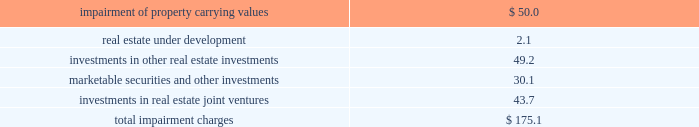Latin american investments during 2009 , the company acquired a land parcel located in rio clara , brazil through a newly formed consolidated joint venture in which the company has a 70% ( 70 % ) controlling ownership interest for a purchase price of 3.3 million brazilian reals ( approximately usd $ 1.5 million ) .
This parcel will be developed into a 48000 square foot retail shopping center .
Additionally , during 2009 , the company acquired a land parcel located in san luis potosi , mexico , through an unconsolidated joint venture in which the company has a noncontrolling interest , for an aggregate purchase price of approximately $ 0.8 million .
The company recognized equity in income from its unconsolidated mexican investments in real estate joint ventures of approximately $ 7.0 million , $ 17.1 million , and $ 5.2 million during 2009 , 2008 and 2007 , respectively .
The company recognized equity in income from its unconsolidated chilean investments in real estate joint ventures of approximately $ 0.4 million , $ 0.2 and $ 0.1 million during 2009 , 2008 and 2007 , respectively .
The company 2019s revenues from its consolidated mexican subsidiaries aggregated approximately $ 23.4 million , $ 20.3 million , $ 8.5 million during 2009 , 2008 and 2007 , respectively .
The company 2019s revenues from its consolidated brazilian subsidiaries aggregated approximately $ 1.5 million and $ 0.4 million during 2009 and 2008 , respectively .
The company 2019s revenues from its consolidated chilean subsidiaries aggregated less than $ 100000 during 2009 and 2008 , respectively .
Mortgages and other financing receivables during 2009 , the company provided financing to five borrowers for an aggregate amount of approximately $ 8.3 million .
During 2009 , the company received an aggregate of approximately $ 40.4 million which fully paid down the outstanding balance on four mortgage receivables .
As of december 31 , 2009 , the company had 37 loans with total commitments of up to $ 178.9 million , of which approximately $ 131.3 million has been funded .
Availability under the company 2019s revolving credit facilities are expected to be sufficient to fund these remaining commitments .
( see note 10 of the notes to consolidated financial statements included in this annual report on form 10-k. ) asset impairments on a continuous basis , management assesses whether there are any indicators , including property operating performance and general market conditions , that the value of the company 2019s assets ( including any related amortizable intangible assets or liabilities ) may be impaired .
To the extent impairment has occurred , the carrying value of the asset would be adjusted to an amount to reflect the estimated fair value of the asset .
During 2009 , economic conditions had continued to experience volatility resulting in further declines in the real estate and equity markets .
Year over year increases in capitalization rates , discount rates and vacancies as well as the deterioration of real estate market fundamentals , negatively impacted net operating income and leasing which further contributed to declines in real estate markets in general .
As a result of the volatility and declining market conditions described above , as well as the company 2019s strategy in relation to certain of its non-retail assets , the company recognized non-cash impairment charges during 2009 , aggregating approximately $ 175.1 million , before income tax benefit of approximately $ 22.5 million and noncontrolling interests of approximately $ 1.2 million .
Details of these non-cash impairment charges are as follows ( in millions ) : .
( see notes 2 , 6 , 8 , 9 , 10 and 11 of the notes to consolidated financial statements included in this annual report on form 10-k. ) .
In 2009 what was the percent of the income tax benefit and the noncontrolling interests of the the company recognized non-cash impairment charges? 
Computations: ((22.5 + 1.2) + 175.1)
Answer: 198.8. 